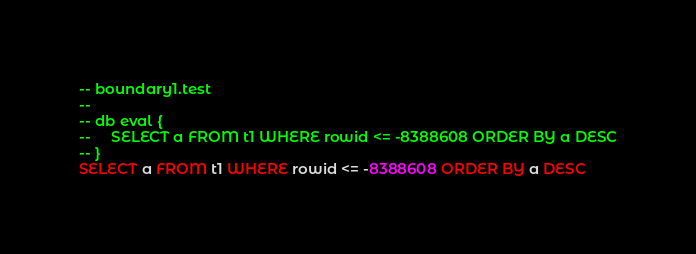<code> <loc_0><loc_0><loc_500><loc_500><_SQL_>-- boundary1.test
-- 
-- db eval {
--     SELECT a FROM t1 WHERE rowid <= -8388608 ORDER BY a DESC
-- }
SELECT a FROM t1 WHERE rowid <= -8388608 ORDER BY a DESC</code> 